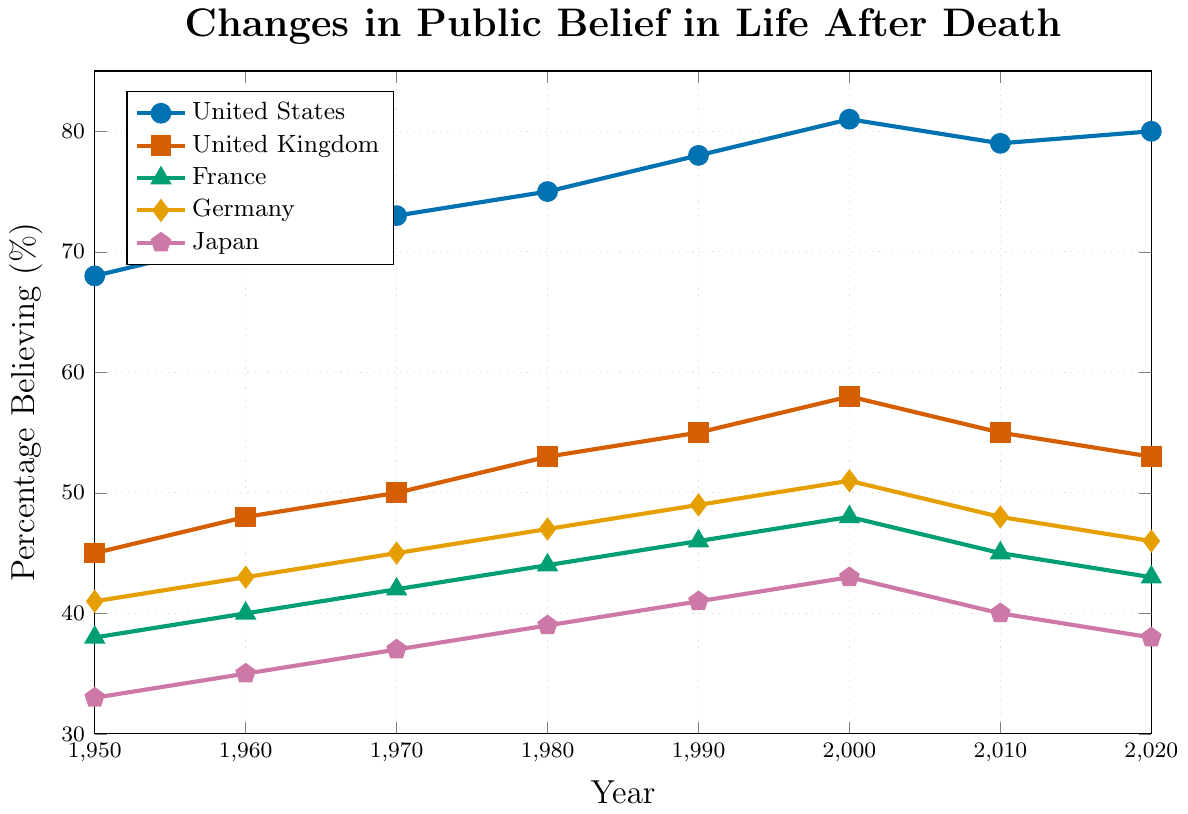What's the overall trend in public belief in life after death for the United States from 1950 to 2020? To determine the overall trend, examine the data points for the United States from 1950 to 2020. The percentage believing in life after death increases from 68% in 1950 to 80% in 2020.
Answer: Increasing Which country showed the largest increase in the percentage of belief in life after death from 1950 to 2020? Calculate the increase for each country by subtracting the 1950 value from the 2020 value. United States: 80-68=12, United Kingdom: 53-45=8, France: 43-38=5, Germany: 46-41=5, Japan: 38-33=5. The largest increase is in the United States.
Answer: United States In 1990, was the percentage of people believing in life after death higher in the United States or in the United Kingdom? Compare the 1990 data points: United States (78%) and United Kingdom (55%). The percentage is higher in the United States.
Answer: United States Between which consecutive decades did the United Kingdom show the smallest increase in belief percentage? Calculate the increase between consecutive decades for the United Kingdom. 1950-1960: 3, 1960-1970: 2, 1970-1980: 3, 1980-1990: 2, 1990-2000: 3, 2000-2010: -3, 2010-2020: -2. The smallest increase (negative in this case) occurred between 2000 and 2010.
Answer: 2000 to 2010 How does the trend in France compare to the trend in Germany from 1950 to 2020? Both France and Germany show an increasing trend from 1950 to 2000, with France rising from 38% to 48% and Germany from 41% to 51%. After 2000, both countries show a decrease, with France dropping to 43% by 2020, and Germany to 46%, reflecting a similar overall pattern.
Answer: Similar trend What is the average percentage of belief in life after death in Japan across all the decades shown? Calculate the average of the percentages for Japan: (33 + 35 + 37 + 39 + 41 + 43 + 40 + 38)/8 = 38.25.
Answer: 38.25 Which country had the lowest percentage of belief in life after death in 1980? Look at the 1980 values: United States (75%), United Kingdom (53%), France (44%), Germany (47%), Japan (39%). The lowest percentage is in Japan (39%).
Answer: Japan 